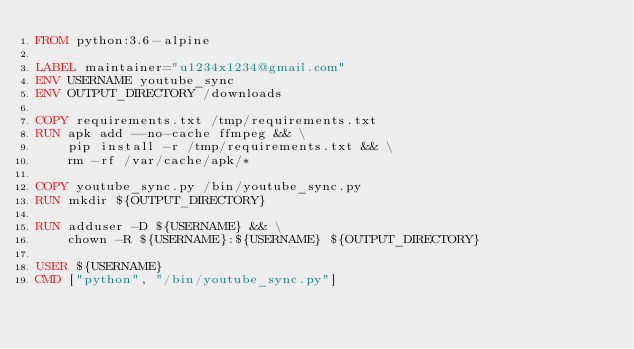<code> <loc_0><loc_0><loc_500><loc_500><_Dockerfile_>FROM python:3.6-alpine

LABEL maintainer="u1234x1234@gmail.com"
ENV USERNAME youtube_sync
ENV OUTPUT_DIRECTORY /downloads

COPY requirements.txt /tmp/requirements.txt
RUN apk add --no-cache ffmpeg && \
    pip install -r /tmp/requirements.txt && \
    rm -rf /var/cache/apk/*

COPY youtube_sync.py /bin/youtube_sync.py
RUN mkdir ${OUTPUT_DIRECTORY}

RUN adduser -D ${USERNAME} && \
    chown -R ${USERNAME}:${USERNAME} ${OUTPUT_DIRECTORY}

USER ${USERNAME}
CMD ["python", "/bin/youtube_sync.py"]
</code> 